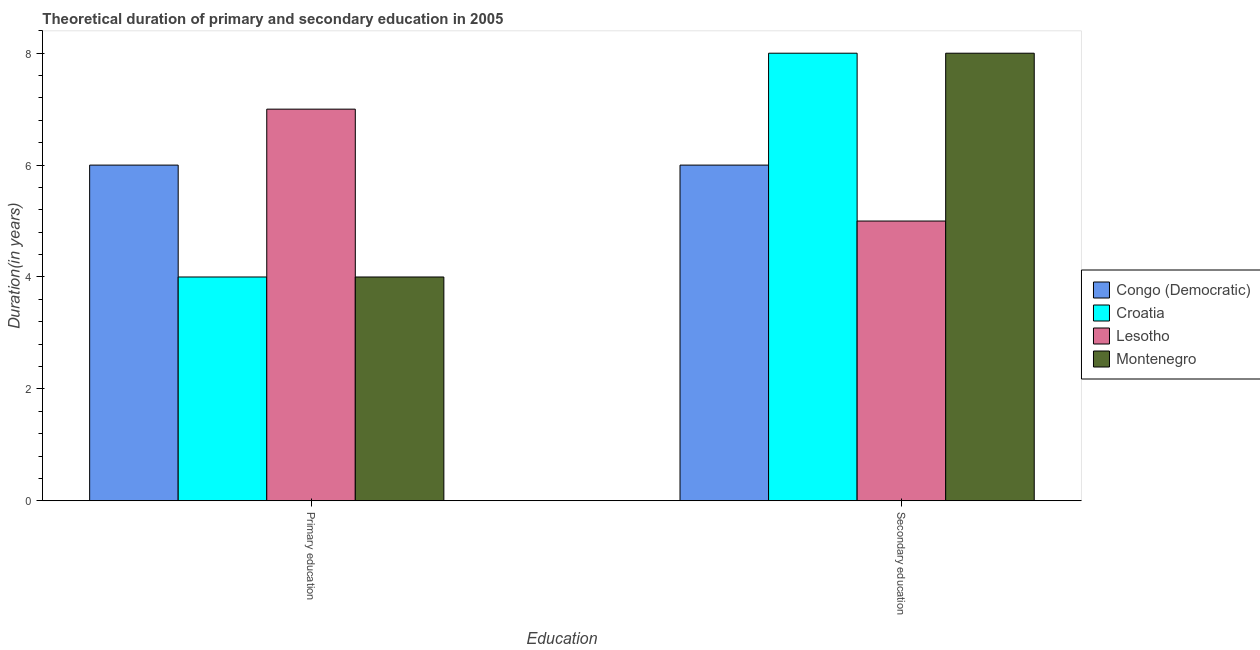How many different coloured bars are there?
Your answer should be very brief. 4. How many groups of bars are there?
Keep it short and to the point. 2. Are the number of bars on each tick of the X-axis equal?
Provide a succinct answer. Yes. How many bars are there on the 1st tick from the left?
Keep it short and to the point. 4. What is the label of the 1st group of bars from the left?
Your answer should be very brief. Primary education. Across all countries, what is the maximum duration of secondary education?
Your answer should be very brief. 8. Across all countries, what is the minimum duration of secondary education?
Keep it short and to the point. 5. In which country was the duration of secondary education maximum?
Give a very brief answer. Croatia. In which country was the duration of secondary education minimum?
Make the answer very short. Lesotho. What is the total duration of secondary education in the graph?
Your answer should be compact. 27. What is the difference between the duration of primary education in Croatia and the duration of secondary education in Lesotho?
Provide a short and direct response. -1. What is the average duration of primary education per country?
Make the answer very short. 5.25. What is the difference between the duration of secondary education and duration of primary education in Lesotho?
Provide a short and direct response. -2. What is the ratio of the duration of secondary education in Montenegro to that in Congo (Democratic)?
Ensure brevity in your answer.  1.33. Is the duration of primary education in Lesotho less than that in Croatia?
Ensure brevity in your answer.  No. In how many countries, is the duration of primary education greater than the average duration of primary education taken over all countries?
Provide a succinct answer. 2. What does the 1st bar from the left in Secondary education represents?
Your answer should be very brief. Congo (Democratic). What does the 3rd bar from the right in Secondary education represents?
Provide a succinct answer. Croatia. What is the difference between two consecutive major ticks on the Y-axis?
Your answer should be compact. 2. Does the graph contain any zero values?
Offer a very short reply. No. Does the graph contain grids?
Offer a terse response. No. Where does the legend appear in the graph?
Offer a very short reply. Center right. How many legend labels are there?
Provide a short and direct response. 4. How are the legend labels stacked?
Provide a succinct answer. Vertical. What is the title of the graph?
Your answer should be compact. Theoretical duration of primary and secondary education in 2005. Does "Honduras" appear as one of the legend labels in the graph?
Offer a very short reply. No. What is the label or title of the X-axis?
Keep it short and to the point. Education. What is the label or title of the Y-axis?
Offer a very short reply. Duration(in years). What is the Duration(in years) of Congo (Democratic) in Primary education?
Your answer should be compact. 6. What is the Duration(in years) of Croatia in Primary education?
Your answer should be compact. 4. What is the Duration(in years) in Lesotho in Primary education?
Provide a succinct answer. 7. What is the Duration(in years) in Montenegro in Primary education?
Offer a terse response. 4. What is the Duration(in years) in Croatia in Secondary education?
Ensure brevity in your answer.  8. What is the Duration(in years) of Lesotho in Secondary education?
Offer a very short reply. 5. What is the Duration(in years) in Montenegro in Secondary education?
Your answer should be very brief. 8. Across all Education, what is the maximum Duration(in years) in Croatia?
Make the answer very short. 8. Across all Education, what is the maximum Duration(in years) of Lesotho?
Ensure brevity in your answer.  7. Across all Education, what is the maximum Duration(in years) of Montenegro?
Provide a succinct answer. 8. Across all Education, what is the minimum Duration(in years) of Croatia?
Offer a terse response. 4. What is the total Duration(in years) in Montenegro in the graph?
Offer a terse response. 12. What is the difference between the Duration(in years) of Croatia in Primary education and that in Secondary education?
Make the answer very short. -4. What is the difference between the Duration(in years) in Congo (Democratic) in Primary education and the Duration(in years) in Croatia in Secondary education?
Your answer should be very brief. -2. What is the difference between the Duration(in years) of Congo (Democratic) in Primary education and the Duration(in years) of Lesotho in Secondary education?
Provide a succinct answer. 1. What is the difference between the Duration(in years) in Congo (Democratic) in Primary education and the Duration(in years) in Montenegro in Secondary education?
Keep it short and to the point. -2. What is the difference between the Duration(in years) of Croatia in Primary education and the Duration(in years) of Montenegro in Secondary education?
Give a very brief answer. -4. What is the average Duration(in years) in Congo (Democratic) per Education?
Your answer should be very brief. 6. What is the average Duration(in years) in Croatia per Education?
Offer a very short reply. 6. What is the average Duration(in years) of Montenegro per Education?
Give a very brief answer. 6. What is the difference between the Duration(in years) in Congo (Democratic) and Duration(in years) in Croatia in Primary education?
Make the answer very short. 2. What is the difference between the Duration(in years) in Congo (Democratic) and Duration(in years) in Montenegro in Primary education?
Keep it short and to the point. 2. What is the difference between the Duration(in years) in Croatia and Duration(in years) in Lesotho in Primary education?
Keep it short and to the point. -3. What is the difference between the Duration(in years) in Congo (Democratic) and Duration(in years) in Croatia in Secondary education?
Provide a succinct answer. -2. What is the difference between the Duration(in years) of Croatia and Duration(in years) of Lesotho in Secondary education?
Offer a terse response. 3. What is the difference between the Duration(in years) of Croatia and Duration(in years) of Montenegro in Secondary education?
Make the answer very short. 0. What is the difference between the Duration(in years) of Lesotho and Duration(in years) of Montenegro in Secondary education?
Your answer should be compact. -3. What is the ratio of the Duration(in years) in Lesotho in Primary education to that in Secondary education?
Ensure brevity in your answer.  1.4. What is the difference between the highest and the second highest Duration(in years) in Croatia?
Give a very brief answer. 4. What is the difference between the highest and the second highest Duration(in years) in Montenegro?
Your response must be concise. 4. What is the difference between the highest and the lowest Duration(in years) of Croatia?
Ensure brevity in your answer.  4. What is the difference between the highest and the lowest Duration(in years) of Lesotho?
Offer a terse response. 2. What is the difference between the highest and the lowest Duration(in years) of Montenegro?
Keep it short and to the point. 4. 